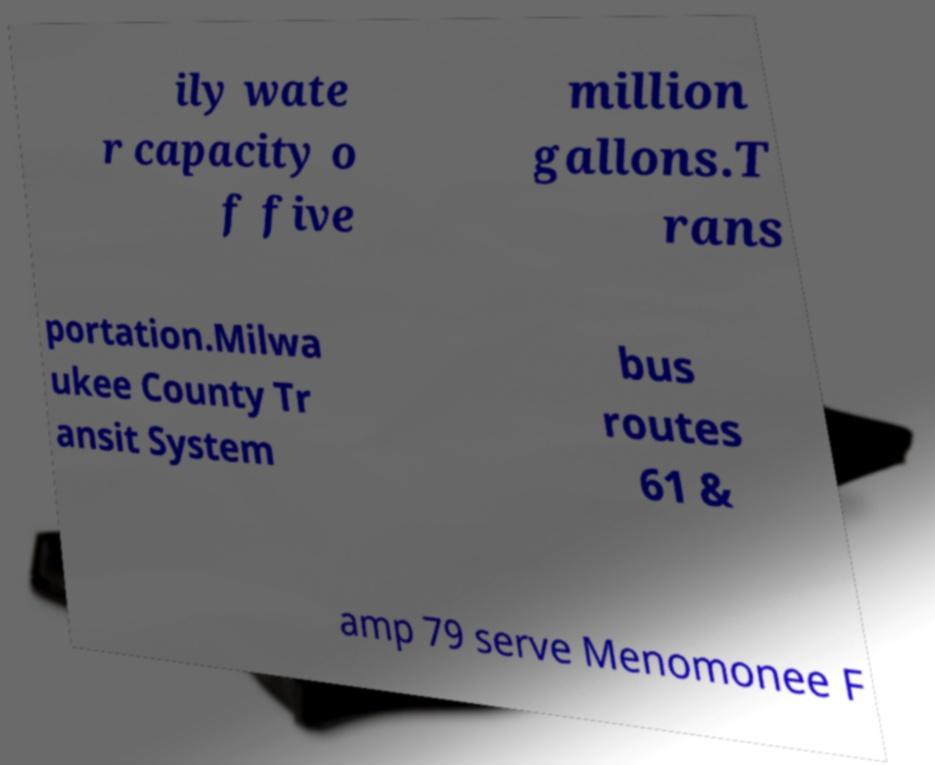Could you assist in decoding the text presented in this image and type it out clearly? ily wate r capacity o f five million gallons.T rans portation.Milwa ukee County Tr ansit System bus routes 61 & amp 79 serve Menomonee F 